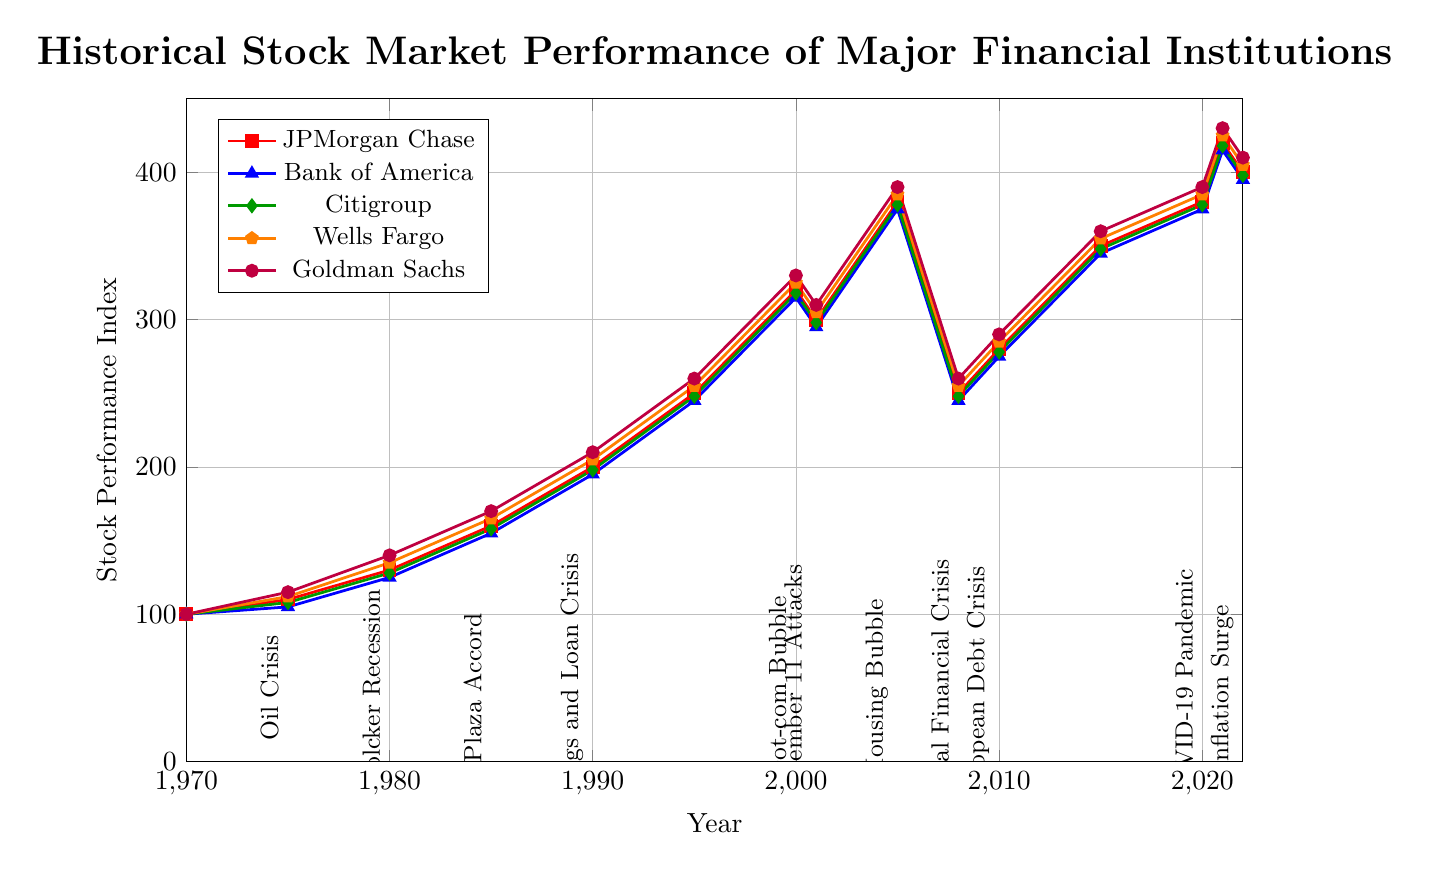What was the general trend in the stock performance of Citigroup from 1970 to 2022? To understand the trend, we need to look at the overall direction of the Citigroup line from 1970 to 2022. The line starts at 100 in 1970 and ends at 398 in 2022. This indicates an overall upward trend despite some fluctuations during certain periods such as the Global Financial Crisis.
Answer: Upward trend Which financial institution had the highest stock performance in 2021? To answer this, we should look at the data points of all financial institutions in 2021. The stock performance indices are: JPMorgan Chase (420), Bank of America (415), Citigroup (418), Wells Fargo (425), and Goldman Sachs (430). Goldman Sachs had the highest performance.
Answer: Goldman Sachs During the Global Financial Crisis in 2008, which two banks saw their stock performance fall to 245 and 248 respectively? We need to refer to the 2008 data points. Bank of America fell to 245 and Citigroup fell to 248.
Answer: Bank of America and Citigroup What was the stock performance of Wells Fargo during the Dot-com Bubble in 2000? Checking the data for Wells Fargo in 2000, we see a stock performance value of 325.
Answer: 325 How did the stock performance of JPMorgan Chase change from 2008 to 2010? Looking at JPMorgan Chase's stock performance in 2008 and 2010, we see it was 250 in 2008 and 280 in 2010. The change is calculated as 280 - 250 = 30.
Answer: Increased by 30 Between 1970 and 2022, which financial institution had the most consistent growth without significant drops? By observing the lines representing each financial institution, we notice that despite some fluctuations, Goldman Sachs exhibits a relatively smoother upward trend without significant drops as seen in other institutions during crises.
Answer: Goldman Sachs Which economic event appears to have had the longest-lasting negative impact on the stock performance of the banks? Looking at the durations of dips in stock performance after major economic events, the Global Financial Crisis in 2008 had a noticeable and prolonged negative impact. Stocks took several years to recover from this downturn.
Answer: Global Financial Crisis How did the economic event "September 11 Attacks" in 2001 affect the stock performance of Bank of America? Looking at the 2000 and 2001 stock performance values for Bank of America, in 2000 it was 315, and in 2001 it dropped to 295. The drop due to the September 11 Attacks is 315 - 295 = 20.
Answer: Decreased by 20 What was the average stock performance index of Goldman Sachs during the COVID-19 Pandemic in 2020 and 2021? The stock performance indices for Goldman Sachs during 2020 and 2021 are 390 and 430, respectively. Average is calculated as (390 + 430) / 2 = 410.
Answer: 410 